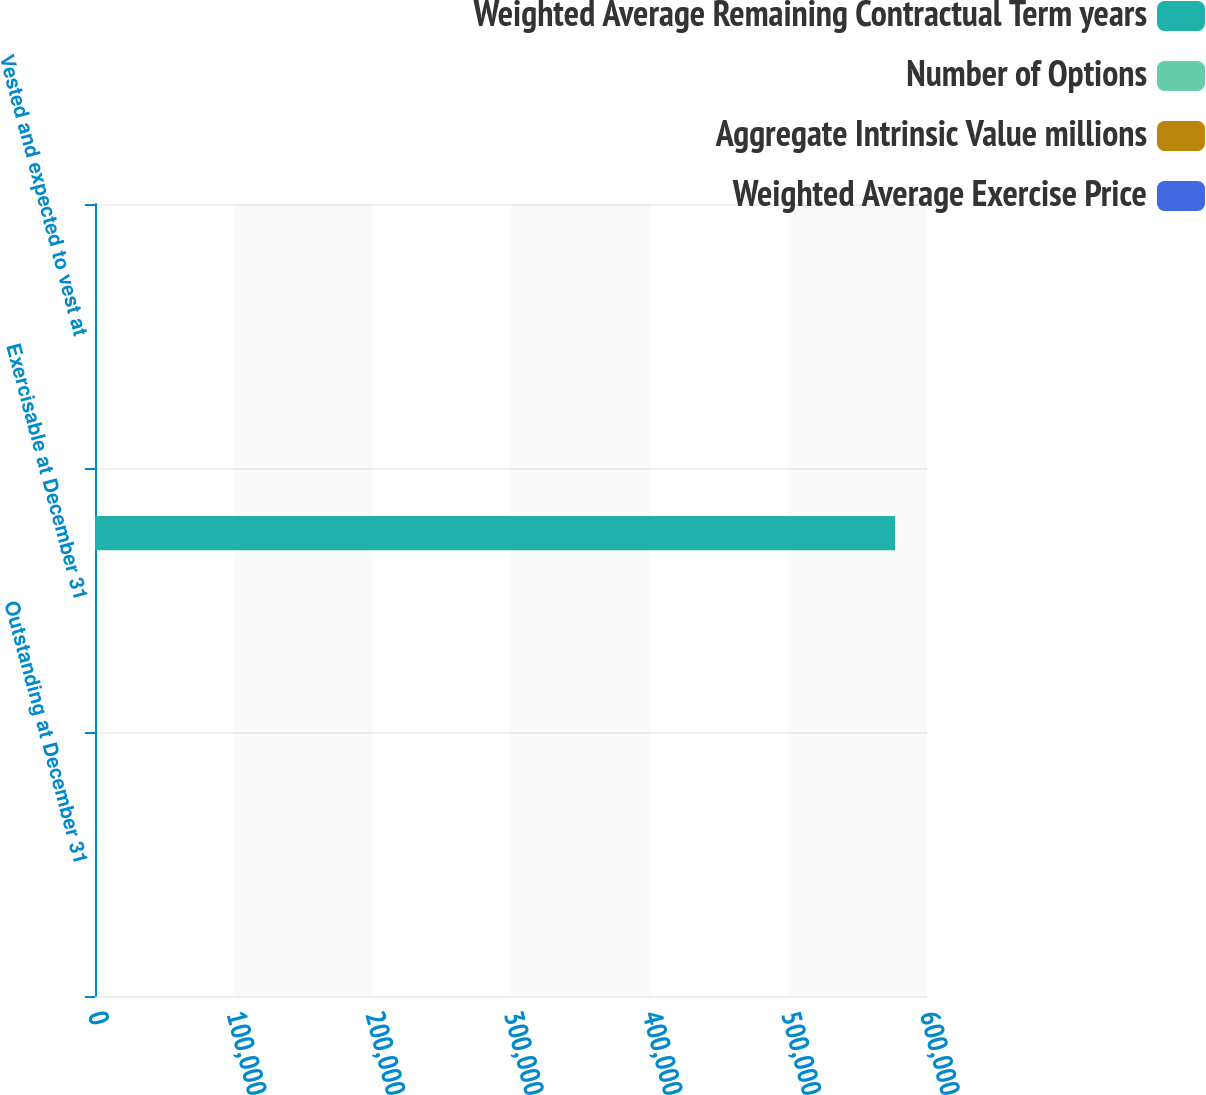Convert chart to OTSL. <chart><loc_0><loc_0><loc_500><loc_500><stacked_bar_chart><ecel><fcel>Outstanding at December 31<fcel>Exercisable at December 31<fcel>Vested and expected to vest at<nl><fcel>Weighted Average Remaining Contractual Term years<fcel>18.87<fcel>576963<fcel>18.87<nl><fcel>Number of Options<fcel>20.75<fcel>17<fcel>20.74<nl><fcel>Aggregate Intrinsic Value millions<fcel>8.3<fcel>7.2<fcel>8.3<nl><fcel>Weighted Average Exercise Price<fcel>34.9<fcel>10.5<fcel>34.3<nl></chart> 